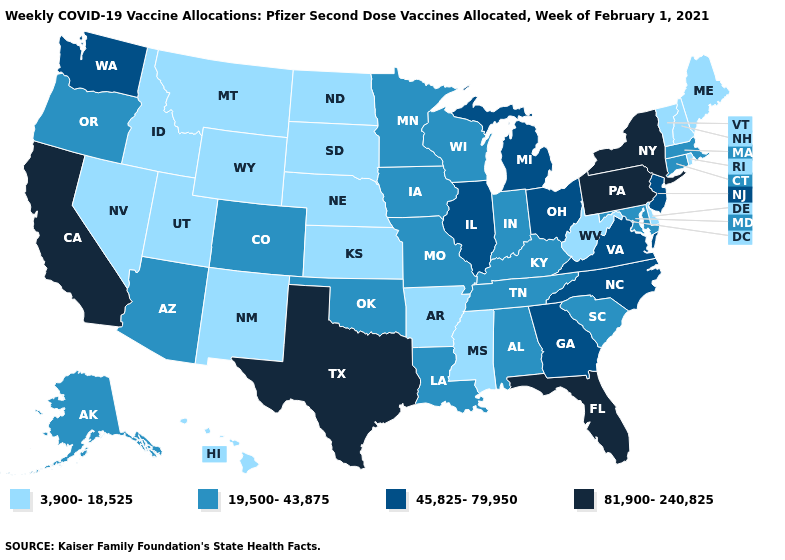What is the value of Pennsylvania?
Keep it brief. 81,900-240,825. Which states have the lowest value in the Northeast?
Write a very short answer. Maine, New Hampshire, Rhode Island, Vermont. Does New York have the lowest value in the Northeast?
Concise answer only. No. What is the highest value in the USA?
Write a very short answer. 81,900-240,825. Which states have the lowest value in the Northeast?
Write a very short answer. Maine, New Hampshire, Rhode Island, Vermont. What is the value of Delaware?
Give a very brief answer. 3,900-18,525. Does Texas have the highest value in the South?
Keep it brief. Yes. What is the lowest value in the West?
Keep it brief. 3,900-18,525. What is the value of Missouri?
Write a very short answer. 19,500-43,875. Name the states that have a value in the range 45,825-79,950?
Answer briefly. Georgia, Illinois, Michigan, New Jersey, North Carolina, Ohio, Virginia, Washington. Among the states that border Vermont , which have the lowest value?
Give a very brief answer. New Hampshire. Does the map have missing data?
Short answer required. No. Name the states that have a value in the range 19,500-43,875?
Be succinct. Alabama, Alaska, Arizona, Colorado, Connecticut, Indiana, Iowa, Kentucky, Louisiana, Maryland, Massachusetts, Minnesota, Missouri, Oklahoma, Oregon, South Carolina, Tennessee, Wisconsin. What is the lowest value in the USA?
Short answer required. 3,900-18,525. Does Washington have the same value as Alabama?
Short answer required. No. 